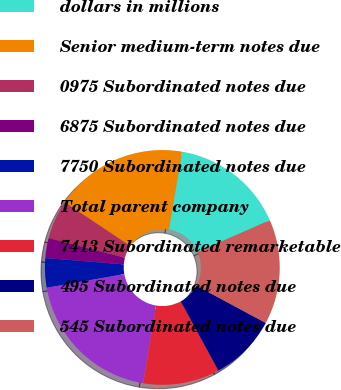Convert chart to OTSL. <chart><loc_0><loc_0><loc_500><loc_500><pie_chart><fcel>dollars in millions<fcel>Senior medium-term notes due<fcel>0975 Subordinated notes due<fcel>6875 Subordinated notes due<fcel>7750 Subordinated notes due<fcel>Total parent company<fcel>7413 Subordinated remarketable<fcel>495 Subordinated notes due<fcel>545 Subordinated notes due<nl><fcel>15.72%<fcel>18.32%<fcel>5.35%<fcel>2.75%<fcel>4.05%<fcel>19.61%<fcel>10.53%<fcel>9.24%<fcel>14.43%<nl></chart> 